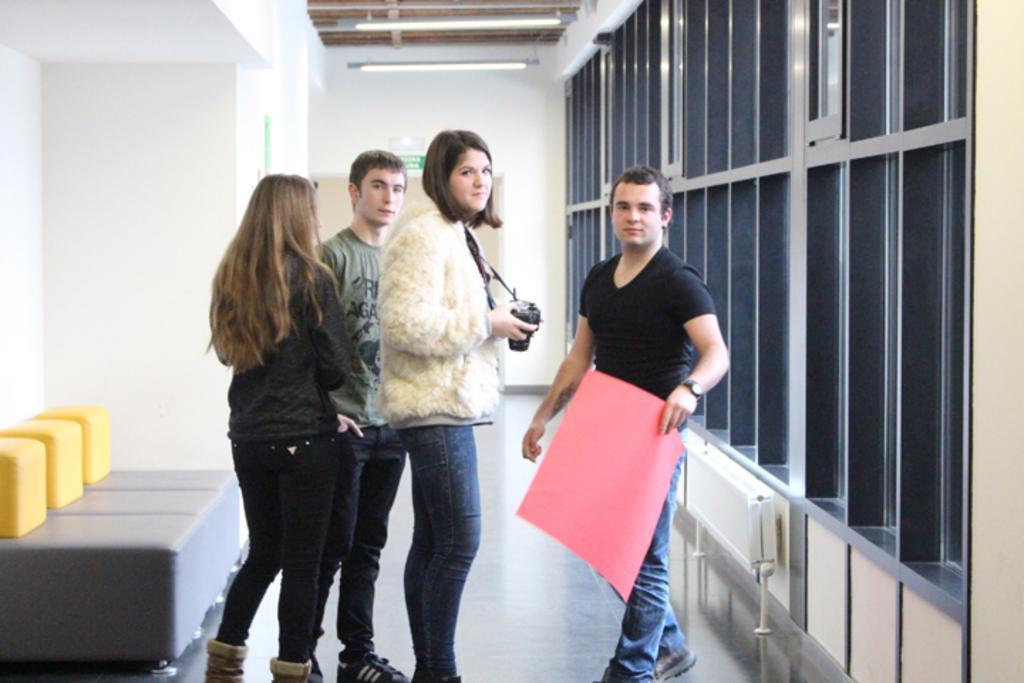How would you summarize this image in a sentence or two? In this image there are some persons standing and one person is holding chart, and one person is holding a camera. On the left side there is a couch and on the right side there are some windows, and in the background there is a wall, doors and lights. At the bottom there is floor. 